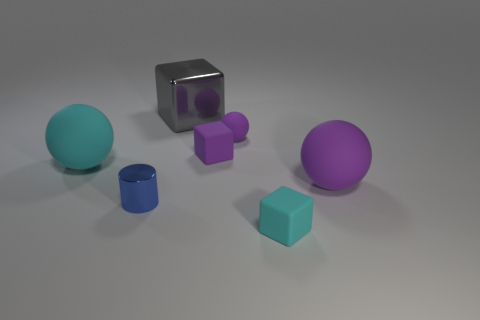Are there more cyan rubber things that are on the left side of the gray metallic cube than blue metallic things?
Your response must be concise. No. Is there anything else that is made of the same material as the big purple thing?
Ensure brevity in your answer.  Yes. The large thing that is the same color as the tiny sphere is what shape?
Your answer should be compact. Sphere. What number of cylinders are either matte things or purple objects?
Your answer should be compact. 0. There is a large sphere in front of the large object to the left of the large gray shiny object; what color is it?
Keep it short and to the point. Purple. There is a small cylinder; is it the same color as the rubber thing left of the gray metallic object?
Offer a terse response. No. The other cyan object that is made of the same material as the big cyan object is what size?
Offer a very short reply. Small. There is a matte block that is the same color as the tiny rubber sphere; what is its size?
Your answer should be compact. Small. Does the big metallic object have the same color as the metal cylinder?
Give a very brief answer. No. Are there any matte blocks on the left side of the small matte thing that is in front of the large sphere that is on the right side of the small cyan matte cube?
Provide a succinct answer. Yes. 